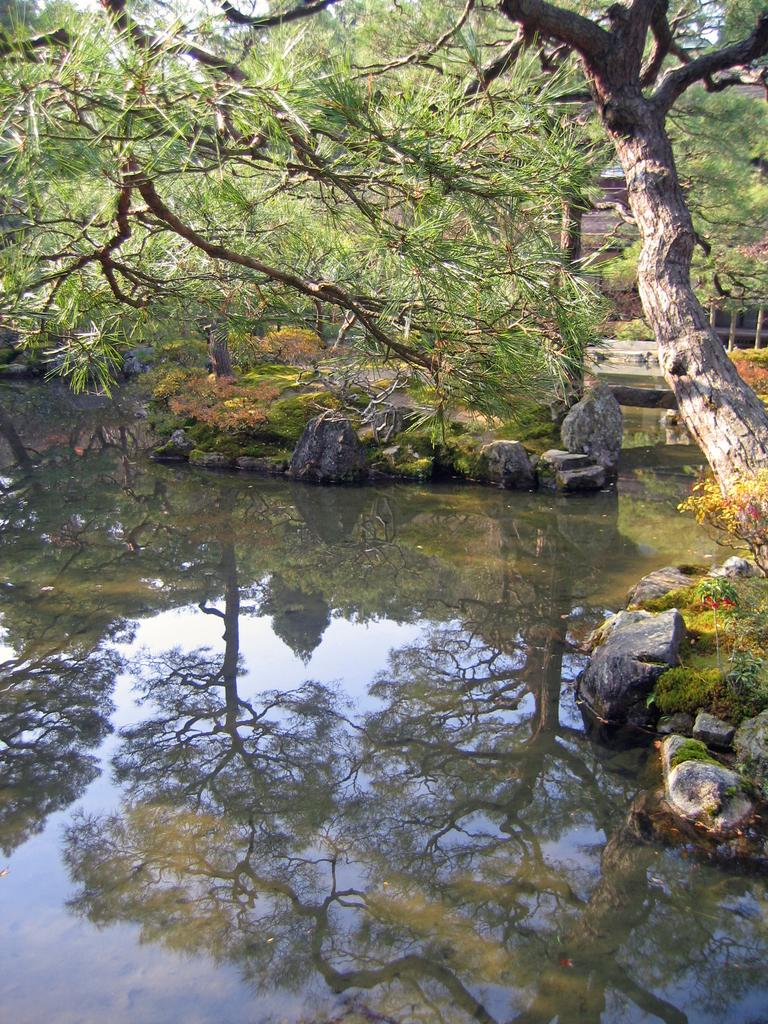What is the primary element visible in the picture? There is water in the picture. What types of vegetation can be seen in the picture? There are plants and trees in the picture. What architectural feature is visible in the background of the picture? There is a fence in the background of the picture. What type of protest is taking place in the picture? There is no protest present in the picture; it features water, plants, trees, and a fence. How many slaves can be seen working in the picture? There are no slaves present in the picture; it features water, plants, trees, and a fence. 